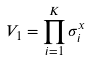<formula> <loc_0><loc_0><loc_500><loc_500>V _ { 1 } = \prod _ { i = 1 } ^ { K } \sigma ^ { x } _ { i }</formula> 